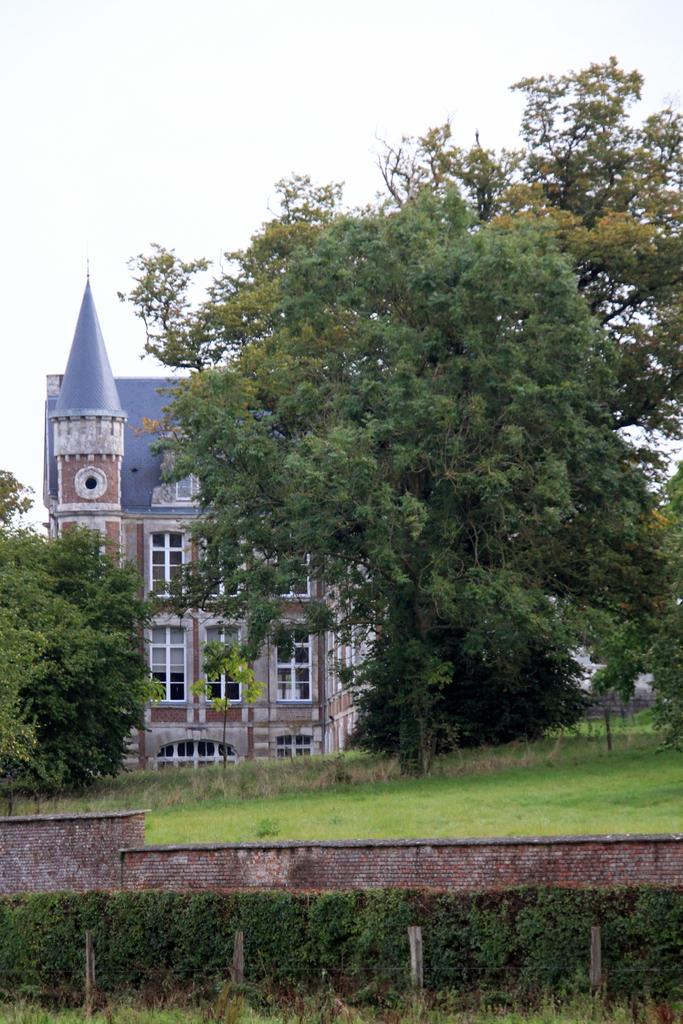What type of vegetation can be seen in the image? There are plants, grass, and trees in the image. What is the primary man-made structure in the image? There is a wall in the image. What is visible in the background of the image? There is a building and the sky visible in the background of the image. What color is the shirt worn by the tree in the image? There are no shirts or trees wearing shirts present in the image. How many wrists can be seen on the plants in the image? There are no wrists visible in the image, as plants do not have wrists. 